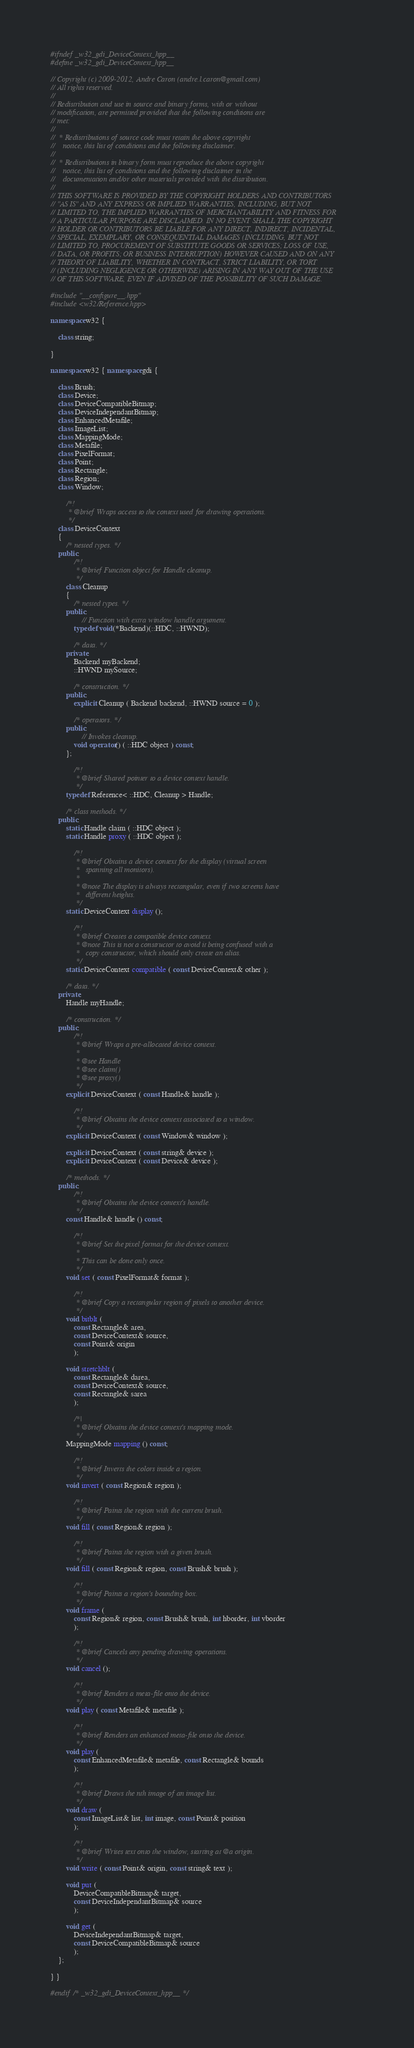<code> <loc_0><loc_0><loc_500><loc_500><_C++_>#ifndef _w32_gdi_DeviceContext_hpp__
#define _w32_gdi_DeviceContext_hpp__

// Copyright (c) 2009-2012, Andre Caron (andre.l.caron@gmail.com)
// All rights reserved.
// 
// Redistribution and use in source and binary forms, with or without
// modification, are permitted provided that the following conditions are
// met:
//
//  * Redistributions of source code must retain the above copyright
//    notice, this list of conditions and the following disclaimer.
//
//  * Redistributions in binary form must reproduce the above copyright
//    notice, this list of conditions and the following disclaimer in the
//    documentation and/or other materials provided with the distribution.
//
// THIS SOFTWARE IS PROVIDED BY THE COPYRIGHT HOLDERS AND CONTRIBUTORS
// "AS IS" AND ANY EXPRESS OR IMPLIED WARRANTIES, INCLUDING, BUT NOT
// LIMITED TO, THE IMPLIED WARRANTIES OF MERCHANTABILITY AND FITNESS FOR
// A PARTICULAR PURPOSE ARE DISCLAIMED. IN NO EVENT SHALL THE COPYRIGHT
// HOLDER OR CONTRIBUTORS BE LIABLE FOR ANY DIRECT, INDIRECT, INCIDENTAL,
// SPECIAL, EXEMPLARY, OR CONSEQUENTIAL DAMAGES (INCLUDING, BUT NOT
// LIMITED TO, PROCUREMENT OF SUBSTITUTE GOODS OR SERVICES; LOSS OF USE,
// DATA, OR PROFITS; OR BUSINESS INTERRUPTION) HOWEVER CAUSED AND ON ANY
// THEORY OF LIABILITY, WHETHER IN CONTRACT, STRICT LIABILITY, OR TORT
// (INCLUDING NEGLIGENCE OR OTHERWISE) ARISING IN ANY WAY OUT OF THE USE
// OF THIS SOFTWARE, EVEN IF ADVISED OF THE POSSIBILITY OF SUCH DAMAGE.

#include "__configure__.hpp"
#include <w32/Reference.hpp>

namespace w32 {

    class string;

}

namespace w32 { namespace gdi {

    class Brush;
    class Device;
    class DeviceCompatibleBitmap;
    class DeviceIndependantBitmap;
    class EnhancedMetafile;
    class ImageList;
    class MappingMode;
    class Metafile;
    class PixelFormat;
    class Point;
    class Rectangle;
    class Region;
    class Window;

        /*!
         * @brief Wraps access to the context used for drawing operations.
         */
    class DeviceContext
    {
        /* nested types. */
    public:
            /*!
             * @brief Function object for Handle cleanup.
             */
        class Cleanup
        {
            /* nested types. */
        public:
                // Function with extra window handle argument.
            typedef void(*Backend)(::HDC, ::HWND);

            /* data. */
        private:
            Backend myBackend;
            ::HWND mySource;

            /* construction. */
        public:
            explicit Cleanup ( Backend backend, ::HWND source = 0 );

            /* operators. */
        public:
                // Invokes cleanup.
            void operator() ( ::HDC object ) const;
        };

            /*!
             * @brief Shared pointer to a device context handle.
             */
        typedef Reference< ::HDC, Cleanup > Handle;

        /* class methods. */
    public:
        static Handle claim ( ::HDC object );
        static Handle proxy ( ::HDC object );

            /*!
             * @brief Obtains a device context for the display (virtual screen
             *   spanning all monitors).
             *
             * @note The display is always rectangular, even if two screens have
             *   different heights.
             */
        static DeviceContext display ();

            /*!
             * @brief Creates a compatible device context.
             * @note This is not a constructor to avoid it being confused with a
             *   copy constructor, which should only create an alias.
             */
        static DeviceContext compatible ( const DeviceContext& other );

        /* data. */
    private:
        Handle myHandle;

        /* construction. */
    public:
            /*!
             * @brief Wraps a pre-allocated device context.
             *
             * @see Handle
             * @see claim()
             * @see proxy()
             */
        explicit DeviceContext ( const Handle& handle );

            /*!
             * @brief Obtains the device context associated to a window.
             */
        explicit DeviceContext ( const Window& window );

        explicit DeviceContext ( const string& device );
        explicit DeviceContext ( const Device& device );

        /* methods. */
    public:
            /*!
             * @brief Obtains the device context's handle.
             */
        const Handle& handle () const;

            /*!
             * @brief Set the pixel format for the device context.
             *
             * This can be done only once.
             */
        void set ( const PixelFormat& format );

            /*!
             * @brief Copy a rectangular region of pixels to another device.
             */
        void bitblt (
            const Rectangle& area,
            const DeviceContext& source,
            const Point& origin
            );

        void stretchblt (
            const Rectangle& darea,
            const DeviceContext& source,
            const Rectangle& sarea
            );

            /*|
             * @brief Obtains the device context's mapping mode.
             */
        MappingMode mapping () const;

            /*!
             * @brief Inverts the colors inside a region.
             */
        void invert ( const Region& region );

            /*!
             * @brief Paints the region with the current brush.
             */
        void fill ( const Region& region );

            /*!
             * @brief Paints the region with a given brush.
             */
        void fill ( const Region& region, const Brush& brush );

            /*!
             * @brief Paints a region's bounding box.
             */
        void frame (
            const Region& region, const Brush& brush, int hborder, int vborder
            );

            /*!
             * @brief Cancels any pending drawing operations.
             */
        void cancel ();

            /*!
             * @brief Renders a meta-file onto the device.
             */
        void play ( const Metafile& metafile );

            /*!
             * @brief Renders an enhanced meta-file onto the device.
             */
        void play (
            const EnhancedMetafile& metafile, const Rectangle& bounds
            );

            /*!
             * @brief Draws the nth image of an image list.
             */
        void draw (
            const ImageList& list, int image, const Point& position
            );

            /*!
             * @brief Writes text onto the window, starting at @a origin.
             */
        void write ( const Point& origin, const string& text );

        void put (
            DeviceCompatibleBitmap& target,
            const DeviceIndependantBitmap& source
            );

        void get (
            DeviceIndependantBitmap& target,
            const DeviceCompatibleBitmap& source
            );
    };

} }

#endif /* _w32_gdi_DeviceContext_hpp__ */
</code> 